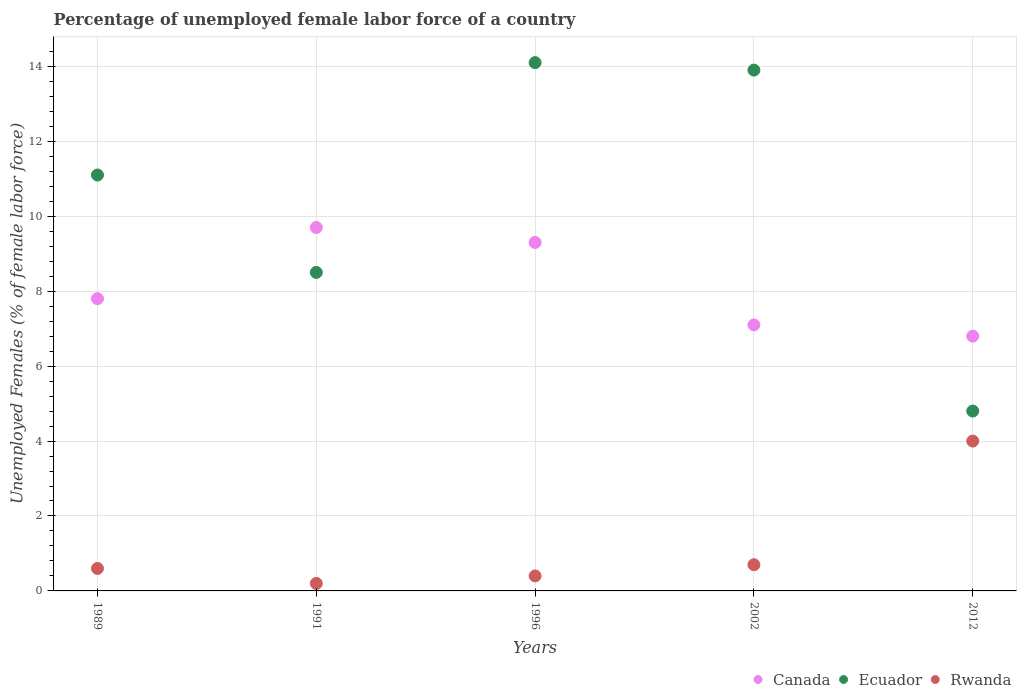How many different coloured dotlines are there?
Give a very brief answer. 3. What is the percentage of unemployed female labor force in Canada in 2002?
Make the answer very short. 7.1. Across all years, what is the maximum percentage of unemployed female labor force in Ecuador?
Your answer should be very brief. 14.1. Across all years, what is the minimum percentage of unemployed female labor force in Canada?
Keep it short and to the point. 6.8. What is the total percentage of unemployed female labor force in Rwanda in the graph?
Your answer should be compact. 5.9. What is the difference between the percentage of unemployed female labor force in Ecuador in 1996 and that in 2002?
Offer a terse response. 0.2. What is the difference between the percentage of unemployed female labor force in Ecuador in 1991 and the percentage of unemployed female labor force in Rwanda in 1989?
Give a very brief answer. 7.9. What is the average percentage of unemployed female labor force in Ecuador per year?
Give a very brief answer. 10.48. In the year 1991, what is the difference between the percentage of unemployed female labor force in Ecuador and percentage of unemployed female labor force in Canada?
Provide a short and direct response. -1.2. In how many years, is the percentage of unemployed female labor force in Ecuador greater than 7.2 %?
Provide a short and direct response. 4. What is the ratio of the percentage of unemployed female labor force in Rwanda in 1991 to that in 2012?
Make the answer very short. 0.05. Is the percentage of unemployed female labor force in Canada in 1989 less than that in 2002?
Make the answer very short. No. What is the difference between the highest and the second highest percentage of unemployed female labor force in Ecuador?
Your response must be concise. 0.2. What is the difference between the highest and the lowest percentage of unemployed female labor force in Canada?
Provide a succinct answer. 2.9. In how many years, is the percentage of unemployed female labor force in Ecuador greater than the average percentage of unemployed female labor force in Ecuador taken over all years?
Provide a succinct answer. 3. Is the sum of the percentage of unemployed female labor force in Ecuador in 1996 and 2012 greater than the maximum percentage of unemployed female labor force in Rwanda across all years?
Make the answer very short. Yes. Is it the case that in every year, the sum of the percentage of unemployed female labor force in Canada and percentage of unemployed female labor force in Rwanda  is greater than the percentage of unemployed female labor force in Ecuador?
Provide a succinct answer. No. Does the percentage of unemployed female labor force in Canada monotonically increase over the years?
Your answer should be compact. No. Is the percentage of unemployed female labor force in Ecuador strictly less than the percentage of unemployed female labor force in Rwanda over the years?
Your answer should be very brief. No. Does the graph contain grids?
Provide a succinct answer. Yes. Where does the legend appear in the graph?
Give a very brief answer. Bottom right. How many legend labels are there?
Offer a very short reply. 3. What is the title of the graph?
Your answer should be very brief. Percentage of unemployed female labor force of a country. What is the label or title of the X-axis?
Offer a terse response. Years. What is the label or title of the Y-axis?
Offer a very short reply. Unemployed Females (% of female labor force). What is the Unemployed Females (% of female labor force) in Canada in 1989?
Give a very brief answer. 7.8. What is the Unemployed Females (% of female labor force) of Ecuador in 1989?
Make the answer very short. 11.1. What is the Unemployed Females (% of female labor force) in Rwanda in 1989?
Your answer should be compact. 0.6. What is the Unemployed Females (% of female labor force) of Canada in 1991?
Your response must be concise. 9.7. What is the Unemployed Females (% of female labor force) of Rwanda in 1991?
Provide a succinct answer. 0.2. What is the Unemployed Females (% of female labor force) of Canada in 1996?
Provide a short and direct response. 9.3. What is the Unemployed Females (% of female labor force) in Ecuador in 1996?
Give a very brief answer. 14.1. What is the Unemployed Females (% of female labor force) of Rwanda in 1996?
Your response must be concise. 0.4. What is the Unemployed Females (% of female labor force) in Canada in 2002?
Your answer should be very brief. 7.1. What is the Unemployed Females (% of female labor force) in Ecuador in 2002?
Keep it short and to the point. 13.9. What is the Unemployed Females (% of female labor force) of Rwanda in 2002?
Your answer should be very brief. 0.7. What is the Unemployed Females (% of female labor force) in Canada in 2012?
Your answer should be very brief. 6.8. What is the Unemployed Females (% of female labor force) in Ecuador in 2012?
Provide a short and direct response. 4.8. Across all years, what is the maximum Unemployed Females (% of female labor force) of Canada?
Your answer should be compact. 9.7. Across all years, what is the maximum Unemployed Females (% of female labor force) of Ecuador?
Your answer should be very brief. 14.1. Across all years, what is the maximum Unemployed Females (% of female labor force) of Rwanda?
Provide a succinct answer. 4. Across all years, what is the minimum Unemployed Females (% of female labor force) in Canada?
Provide a succinct answer. 6.8. Across all years, what is the minimum Unemployed Females (% of female labor force) of Ecuador?
Give a very brief answer. 4.8. Across all years, what is the minimum Unemployed Females (% of female labor force) of Rwanda?
Your answer should be compact. 0.2. What is the total Unemployed Females (% of female labor force) in Canada in the graph?
Offer a terse response. 40.7. What is the total Unemployed Females (% of female labor force) in Ecuador in the graph?
Offer a very short reply. 52.4. What is the difference between the Unemployed Females (% of female labor force) in Canada in 1989 and that in 1991?
Give a very brief answer. -1.9. What is the difference between the Unemployed Females (% of female labor force) of Ecuador in 1989 and that in 1991?
Make the answer very short. 2.6. What is the difference between the Unemployed Females (% of female labor force) of Canada in 1989 and that in 1996?
Your response must be concise. -1.5. What is the difference between the Unemployed Females (% of female labor force) in Ecuador in 1989 and that in 1996?
Ensure brevity in your answer.  -3. What is the difference between the Unemployed Females (% of female labor force) in Canada in 1989 and that in 2002?
Keep it short and to the point. 0.7. What is the difference between the Unemployed Females (% of female labor force) of Ecuador in 1989 and that in 2002?
Your response must be concise. -2.8. What is the difference between the Unemployed Females (% of female labor force) in Canada in 1989 and that in 2012?
Offer a terse response. 1. What is the difference between the Unemployed Females (% of female labor force) of Ecuador in 1989 and that in 2012?
Make the answer very short. 6.3. What is the difference between the Unemployed Females (% of female labor force) in Canada in 1991 and that in 1996?
Make the answer very short. 0.4. What is the difference between the Unemployed Females (% of female labor force) of Rwanda in 1991 and that in 1996?
Provide a succinct answer. -0.2. What is the difference between the Unemployed Females (% of female labor force) of Ecuador in 1991 and that in 2002?
Your answer should be very brief. -5.4. What is the difference between the Unemployed Females (% of female labor force) in Rwanda in 1991 and that in 2002?
Make the answer very short. -0.5. What is the difference between the Unemployed Females (% of female labor force) of Canada in 1991 and that in 2012?
Your answer should be very brief. 2.9. What is the difference between the Unemployed Females (% of female labor force) in Rwanda in 1991 and that in 2012?
Your response must be concise. -3.8. What is the difference between the Unemployed Females (% of female labor force) in Canada in 1996 and that in 2002?
Offer a very short reply. 2.2. What is the difference between the Unemployed Females (% of female labor force) of Canada in 1996 and that in 2012?
Make the answer very short. 2.5. What is the difference between the Unemployed Females (% of female labor force) in Ecuador in 1996 and that in 2012?
Your answer should be compact. 9.3. What is the difference between the Unemployed Females (% of female labor force) of Rwanda in 1996 and that in 2012?
Your answer should be compact. -3.6. What is the difference between the Unemployed Females (% of female labor force) of Ecuador in 2002 and that in 2012?
Make the answer very short. 9.1. What is the difference between the Unemployed Females (% of female labor force) of Canada in 1989 and the Unemployed Females (% of female labor force) of Ecuador in 1991?
Ensure brevity in your answer.  -0.7. What is the difference between the Unemployed Females (% of female labor force) in Canada in 1989 and the Unemployed Females (% of female labor force) in Rwanda in 1991?
Offer a terse response. 7.6. What is the difference between the Unemployed Females (% of female labor force) in Canada in 1989 and the Unemployed Females (% of female labor force) in Ecuador in 1996?
Keep it short and to the point. -6.3. What is the difference between the Unemployed Females (% of female labor force) of Canada in 1989 and the Unemployed Females (% of female labor force) of Ecuador in 2002?
Your answer should be very brief. -6.1. What is the difference between the Unemployed Females (% of female labor force) of Canada in 1989 and the Unemployed Females (% of female labor force) of Rwanda in 2002?
Offer a very short reply. 7.1. What is the difference between the Unemployed Females (% of female labor force) of Canada in 1989 and the Unemployed Females (% of female labor force) of Ecuador in 2012?
Give a very brief answer. 3. What is the difference between the Unemployed Females (% of female labor force) in Canada in 1989 and the Unemployed Females (% of female labor force) in Rwanda in 2012?
Ensure brevity in your answer.  3.8. What is the difference between the Unemployed Females (% of female labor force) in Canada in 1991 and the Unemployed Females (% of female labor force) in Rwanda in 2002?
Your response must be concise. 9. What is the difference between the Unemployed Females (% of female labor force) of Canada in 1991 and the Unemployed Females (% of female labor force) of Ecuador in 2012?
Give a very brief answer. 4.9. What is the difference between the Unemployed Females (% of female labor force) of Ecuador in 1991 and the Unemployed Females (% of female labor force) of Rwanda in 2012?
Offer a terse response. 4.5. What is the difference between the Unemployed Females (% of female labor force) of Canada in 1996 and the Unemployed Females (% of female labor force) of Ecuador in 2002?
Keep it short and to the point. -4.6. What is the difference between the Unemployed Females (% of female labor force) of Canada in 1996 and the Unemployed Females (% of female labor force) of Ecuador in 2012?
Make the answer very short. 4.5. What is the difference between the Unemployed Females (% of female labor force) of Canada in 1996 and the Unemployed Females (% of female labor force) of Rwanda in 2012?
Keep it short and to the point. 5.3. What is the difference between the Unemployed Females (% of female labor force) of Ecuador in 1996 and the Unemployed Females (% of female labor force) of Rwanda in 2012?
Your answer should be compact. 10.1. What is the difference between the Unemployed Females (% of female labor force) of Canada in 2002 and the Unemployed Females (% of female labor force) of Rwanda in 2012?
Offer a very short reply. 3.1. What is the difference between the Unemployed Females (% of female labor force) in Ecuador in 2002 and the Unemployed Females (% of female labor force) in Rwanda in 2012?
Offer a very short reply. 9.9. What is the average Unemployed Females (% of female labor force) of Canada per year?
Your answer should be compact. 8.14. What is the average Unemployed Females (% of female labor force) of Ecuador per year?
Offer a very short reply. 10.48. What is the average Unemployed Females (% of female labor force) in Rwanda per year?
Your answer should be very brief. 1.18. In the year 1989, what is the difference between the Unemployed Females (% of female labor force) of Canada and Unemployed Females (% of female labor force) of Ecuador?
Keep it short and to the point. -3.3. In the year 1989, what is the difference between the Unemployed Females (% of female labor force) of Canada and Unemployed Females (% of female labor force) of Rwanda?
Your answer should be very brief. 7.2. In the year 1989, what is the difference between the Unemployed Females (% of female labor force) in Ecuador and Unemployed Females (% of female labor force) in Rwanda?
Keep it short and to the point. 10.5. In the year 1991, what is the difference between the Unemployed Females (% of female labor force) of Canada and Unemployed Females (% of female labor force) of Ecuador?
Give a very brief answer. 1.2. In the year 1991, what is the difference between the Unemployed Females (% of female labor force) of Canada and Unemployed Females (% of female labor force) of Rwanda?
Your response must be concise. 9.5. In the year 1991, what is the difference between the Unemployed Females (% of female labor force) of Ecuador and Unemployed Females (% of female labor force) of Rwanda?
Your answer should be very brief. 8.3. In the year 1996, what is the difference between the Unemployed Females (% of female labor force) in Canada and Unemployed Females (% of female labor force) in Ecuador?
Offer a very short reply. -4.8. In the year 1996, what is the difference between the Unemployed Females (% of female labor force) of Canada and Unemployed Females (% of female labor force) of Rwanda?
Offer a very short reply. 8.9. In the year 1996, what is the difference between the Unemployed Females (% of female labor force) of Ecuador and Unemployed Females (% of female labor force) of Rwanda?
Offer a very short reply. 13.7. In the year 2002, what is the difference between the Unemployed Females (% of female labor force) in Canada and Unemployed Females (% of female labor force) in Ecuador?
Your answer should be compact. -6.8. What is the ratio of the Unemployed Females (% of female labor force) of Canada in 1989 to that in 1991?
Make the answer very short. 0.8. What is the ratio of the Unemployed Females (% of female labor force) in Ecuador in 1989 to that in 1991?
Your answer should be very brief. 1.31. What is the ratio of the Unemployed Females (% of female labor force) in Canada in 1989 to that in 1996?
Make the answer very short. 0.84. What is the ratio of the Unemployed Females (% of female labor force) in Ecuador in 1989 to that in 1996?
Your answer should be very brief. 0.79. What is the ratio of the Unemployed Females (% of female labor force) of Rwanda in 1989 to that in 1996?
Provide a short and direct response. 1.5. What is the ratio of the Unemployed Females (% of female labor force) in Canada in 1989 to that in 2002?
Provide a short and direct response. 1.1. What is the ratio of the Unemployed Females (% of female labor force) in Ecuador in 1989 to that in 2002?
Offer a terse response. 0.8. What is the ratio of the Unemployed Females (% of female labor force) in Rwanda in 1989 to that in 2002?
Offer a terse response. 0.86. What is the ratio of the Unemployed Females (% of female labor force) of Canada in 1989 to that in 2012?
Your answer should be compact. 1.15. What is the ratio of the Unemployed Females (% of female labor force) of Ecuador in 1989 to that in 2012?
Your answer should be compact. 2.31. What is the ratio of the Unemployed Females (% of female labor force) of Canada in 1991 to that in 1996?
Make the answer very short. 1.04. What is the ratio of the Unemployed Females (% of female labor force) in Ecuador in 1991 to that in 1996?
Provide a succinct answer. 0.6. What is the ratio of the Unemployed Females (% of female labor force) in Rwanda in 1991 to that in 1996?
Your answer should be very brief. 0.5. What is the ratio of the Unemployed Females (% of female labor force) of Canada in 1991 to that in 2002?
Keep it short and to the point. 1.37. What is the ratio of the Unemployed Females (% of female labor force) in Ecuador in 1991 to that in 2002?
Keep it short and to the point. 0.61. What is the ratio of the Unemployed Females (% of female labor force) in Rwanda in 1991 to that in 2002?
Provide a short and direct response. 0.29. What is the ratio of the Unemployed Females (% of female labor force) in Canada in 1991 to that in 2012?
Ensure brevity in your answer.  1.43. What is the ratio of the Unemployed Females (% of female labor force) in Ecuador in 1991 to that in 2012?
Keep it short and to the point. 1.77. What is the ratio of the Unemployed Females (% of female labor force) in Rwanda in 1991 to that in 2012?
Offer a very short reply. 0.05. What is the ratio of the Unemployed Females (% of female labor force) in Canada in 1996 to that in 2002?
Offer a terse response. 1.31. What is the ratio of the Unemployed Females (% of female labor force) in Ecuador in 1996 to that in 2002?
Provide a succinct answer. 1.01. What is the ratio of the Unemployed Females (% of female labor force) of Canada in 1996 to that in 2012?
Keep it short and to the point. 1.37. What is the ratio of the Unemployed Females (% of female labor force) in Ecuador in 1996 to that in 2012?
Your answer should be compact. 2.94. What is the ratio of the Unemployed Females (% of female labor force) in Rwanda in 1996 to that in 2012?
Offer a very short reply. 0.1. What is the ratio of the Unemployed Females (% of female labor force) of Canada in 2002 to that in 2012?
Your answer should be very brief. 1.04. What is the ratio of the Unemployed Females (% of female labor force) in Ecuador in 2002 to that in 2012?
Provide a succinct answer. 2.9. What is the ratio of the Unemployed Females (% of female labor force) in Rwanda in 2002 to that in 2012?
Your answer should be very brief. 0.17. What is the difference between the highest and the second highest Unemployed Females (% of female labor force) in Ecuador?
Offer a very short reply. 0.2. What is the difference between the highest and the lowest Unemployed Females (% of female labor force) in Canada?
Give a very brief answer. 2.9. What is the difference between the highest and the lowest Unemployed Females (% of female labor force) of Ecuador?
Provide a succinct answer. 9.3. What is the difference between the highest and the lowest Unemployed Females (% of female labor force) in Rwanda?
Provide a short and direct response. 3.8. 